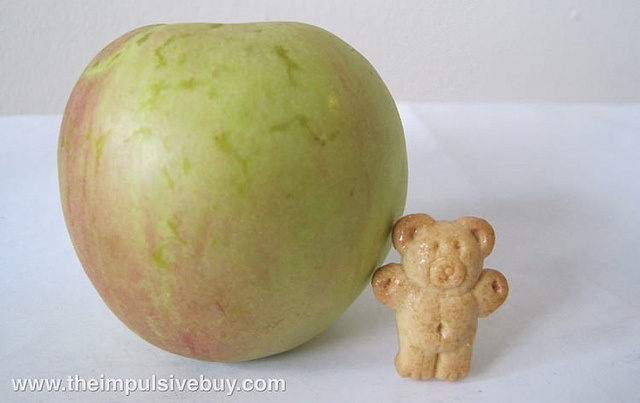Describe the objects in this image and their specific colors. I can see dining table in lightgray, tan, darkgray, and olive tones, apple in lightgray, olive, and khaki tones, and teddy bear in lightgray, tan, and gray tones in this image. 